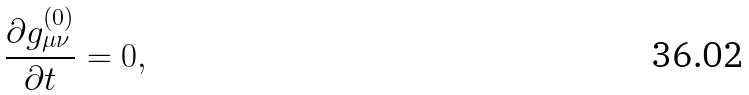<formula> <loc_0><loc_0><loc_500><loc_500>\frac { \partial g _ { \mu \nu } ^ { ( 0 ) } } { \partial t } = 0 ,</formula> 